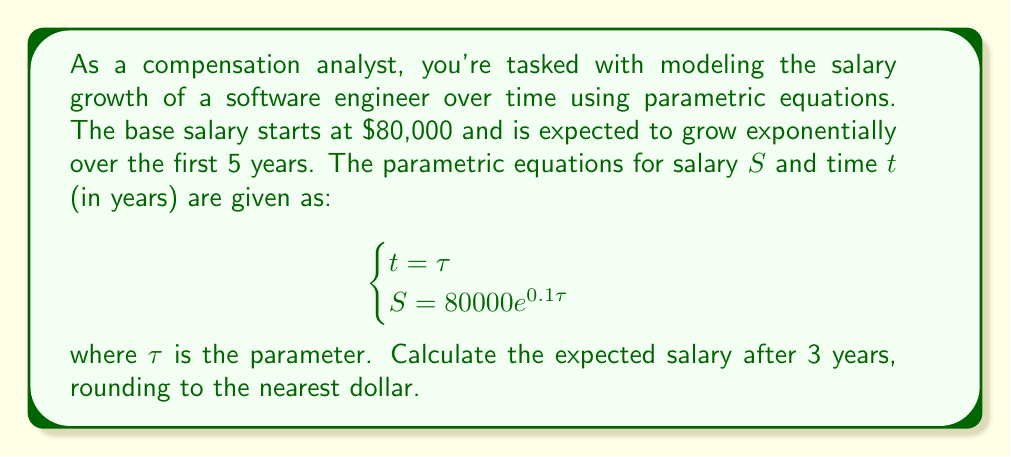Could you help me with this problem? To solve this problem, we'll follow these steps:

1) The parametric equations are given as:
   $$\begin{cases}
   t = \tau \\
   S = 80000e^{0.1\tau}
   \end{cases}$$

2) We're asked to find the salary after 3 years, so we need to set $t = 3$:
   $$3 = \tau$$

3) Now that we know $\tau = 3$, we can substitute this into the equation for $S$:
   $$S = 80000e^{0.1(3)}$$

4) Simplify the exponent:
   $$S = 80000e^{0.3}$$

5) Calculate $e^{0.3}$ (you can use a calculator for this):
   $$e^{0.3} \approx 1.3498588$$

6) Multiply:
   $$S = 80000 \times 1.3498588 \approx 107988.704$$

7) Round to the nearest dollar:
   $$S \approx 107989$$

Therefore, the expected salary after 3 years is $107,989.
Answer: $107,989 